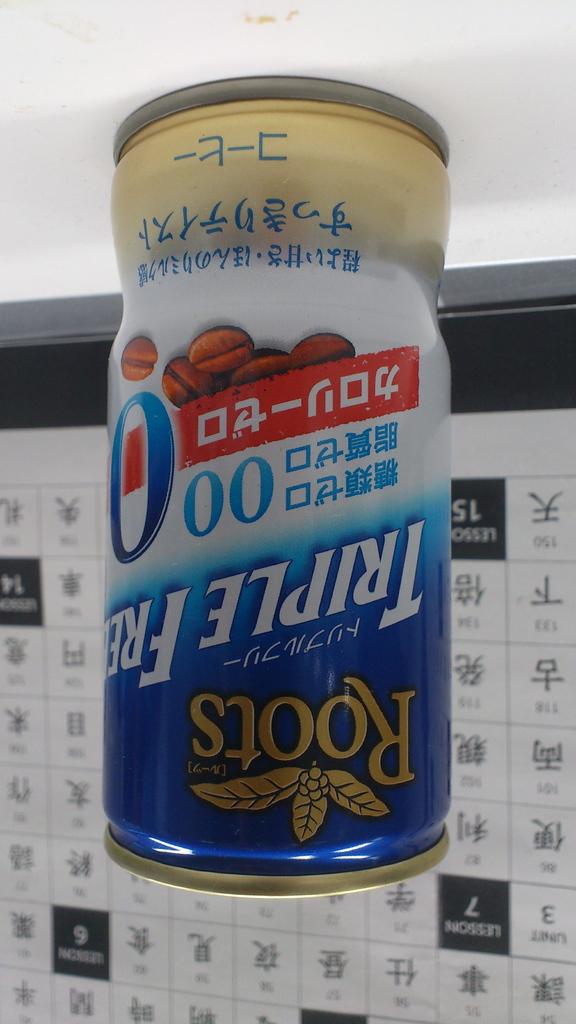What is this beverage called?
Ensure brevity in your answer.  Roots. 